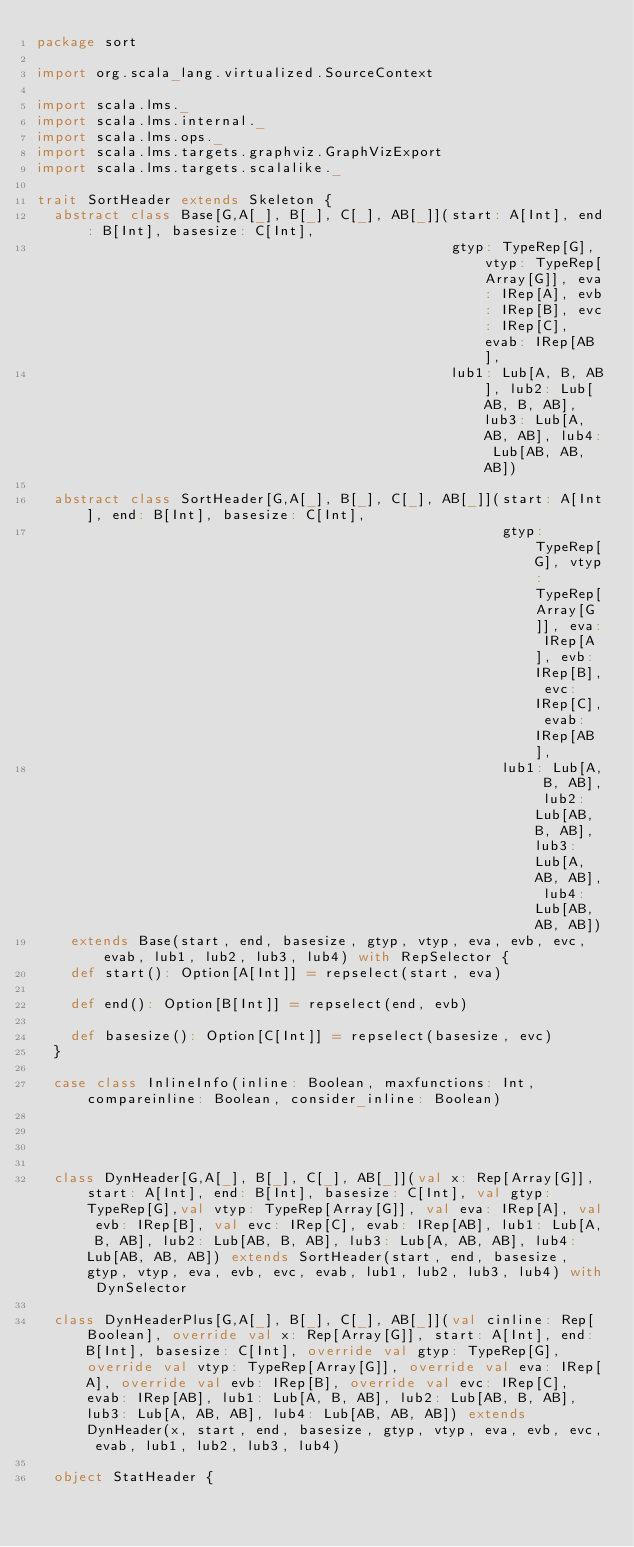<code> <loc_0><loc_0><loc_500><loc_500><_Scala_>package sort

import org.scala_lang.virtualized.SourceContext

import scala.lms._
import scala.lms.internal._
import scala.lms.ops._
import scala.lms.targets.graphviz.GraphVizExport
import scala.lms.targets.scalalike._

trait SortHeader extends Skeleton {
  abstract class Base[G,A[_], B[_], C[_], AB[_]](start: A[Int], end: B[Int], basesize: C[Int],
                                                 gtyp: TypeRep[G], vtyp: TypeRep[Array[G]], eva: IRep[A], evb: IRep[B], evc: IRep[C], evab: IRep[AB],
                                                 lub1: Lub[A, B, AB], lub2: Lub[AB, B, AB], lub3: Lub[A, AB, AB], lub4: Lub[AB, AB, AB])

  abstract class SortHeader[G,A[_], B[_], C[_], AB[_]](start: A[Int], end: B[Int], basesize: C[Int],
                                                       gtyp: TypeRep[G], vtyp: TypeRep[Array[G]], eva: IRep[A], evb: IRep[B], evc: IRep[C], evab: IRep[AB],
                                                       lub1: Lub[A, B, AB], lub2: Lub[AB, B, AB], lub3: Lub[A, AB, AB], lub4: Lub[AB, AB, AB])
    extends Base(start, end, basesize, gtyp, vtyp, eva, evb, evc, evab, lub1, lub2, lub3, lub4) with RepSelector {
    def start(): Option[A[Int]] = repselect(start, eva)

    def end(): Option[B[Int]] = repselect(end, evb)

    def basesize(): Option[C[Int]] = repselect(basesize, evc)
  }

  case class InlineInfo(inline: Boolean, maxfunctions: Int, compareinline: Boolean, consider_inline: Boolean)




  class DynHeader[G,A[_], B[_], C[_], AB[_]](val x: Rep[Array[G]], start: A[Int], end: B[Int], basesize: C[Int], val gtyp: TypeRep[G],val vtyp: TypeRep[Array[G]], val eva: IRep[A], val evb: IRep[B], val evc: IRep[C], evab: IRep[AB], lub1: Lub[A, B, AB], lub2: Lub[AB, B, AB], lub3: Lub[A, AB, AB], lub4: Lub[AB, AB, AB]) extends SortHeader(start, end, basesize, gtyp, vtyp, eva, evb, evc, evab, lub1, lub2, lub3, lub4) with DynSelector

  class DynHeaderPlus[G,A[_], B[_], C[_], AB[_]](val cinline: Rep[Boolean], override val x: Rep[Array[G]], start: A[Int], end: B[Int], basesize: C[Int], override val gtyp: TypeRep[G], override val vtyp: TypeRep[Array[G]], override val eva: IRep[A], override val evb: IRep[B], override val evc: IRep[C], evab: IRep[AB], lub1: Lub[A, B, AB], lub2: Lub[AB, B, AB], lub3: Lub[A, AB, AB], lub4: Lub[AB, AB, AB]) extends DynHeader(x, start, end, basesize, gtyp, vtyp, eva, evb, evc, evab, lub1, lub2, lub3, lub4)

  object StatHeader {</code> 